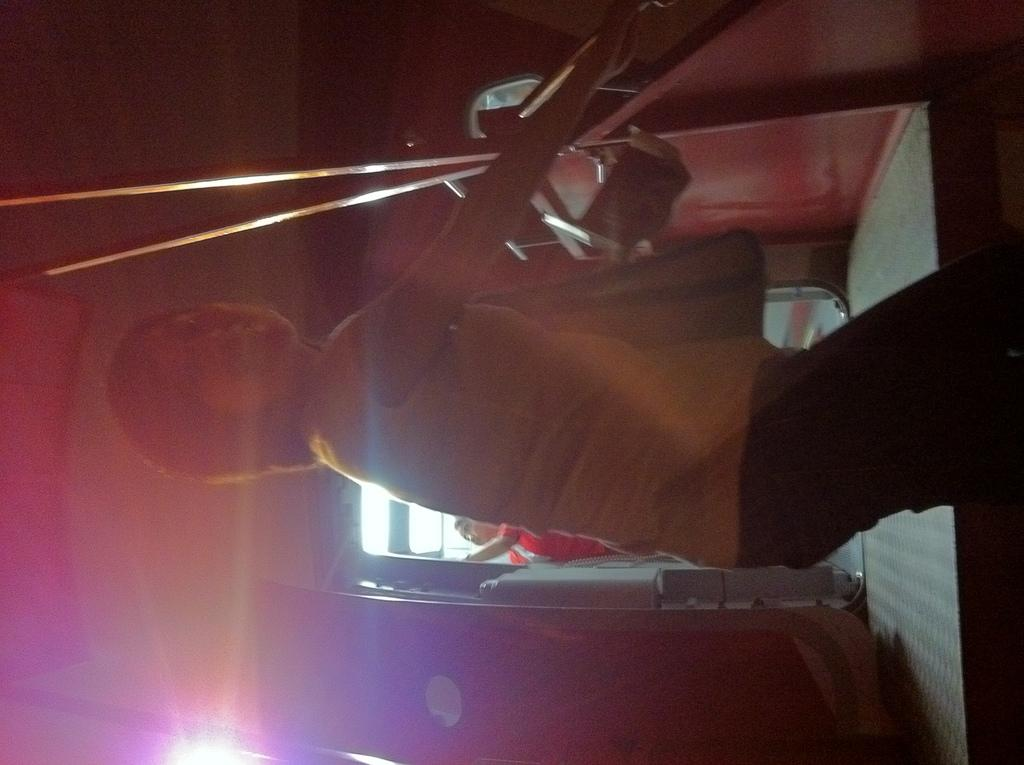What can be seen on the right side of the image? There is a lady on the right side of the image. What is the lady wearing? The lady is wearing a bag. What is the lady doing in the image? The lady is holding onto a wall. Can you describe the person in the background of the image? There is a person standing in the background of the image. What is the lighting condition in the image? There is light in the image. What type of flowers can be seen growing in the wilderness in the image? There are no flowers or wilderness present in the image; it features a lady holding onto a wall and a person standing in the background. 